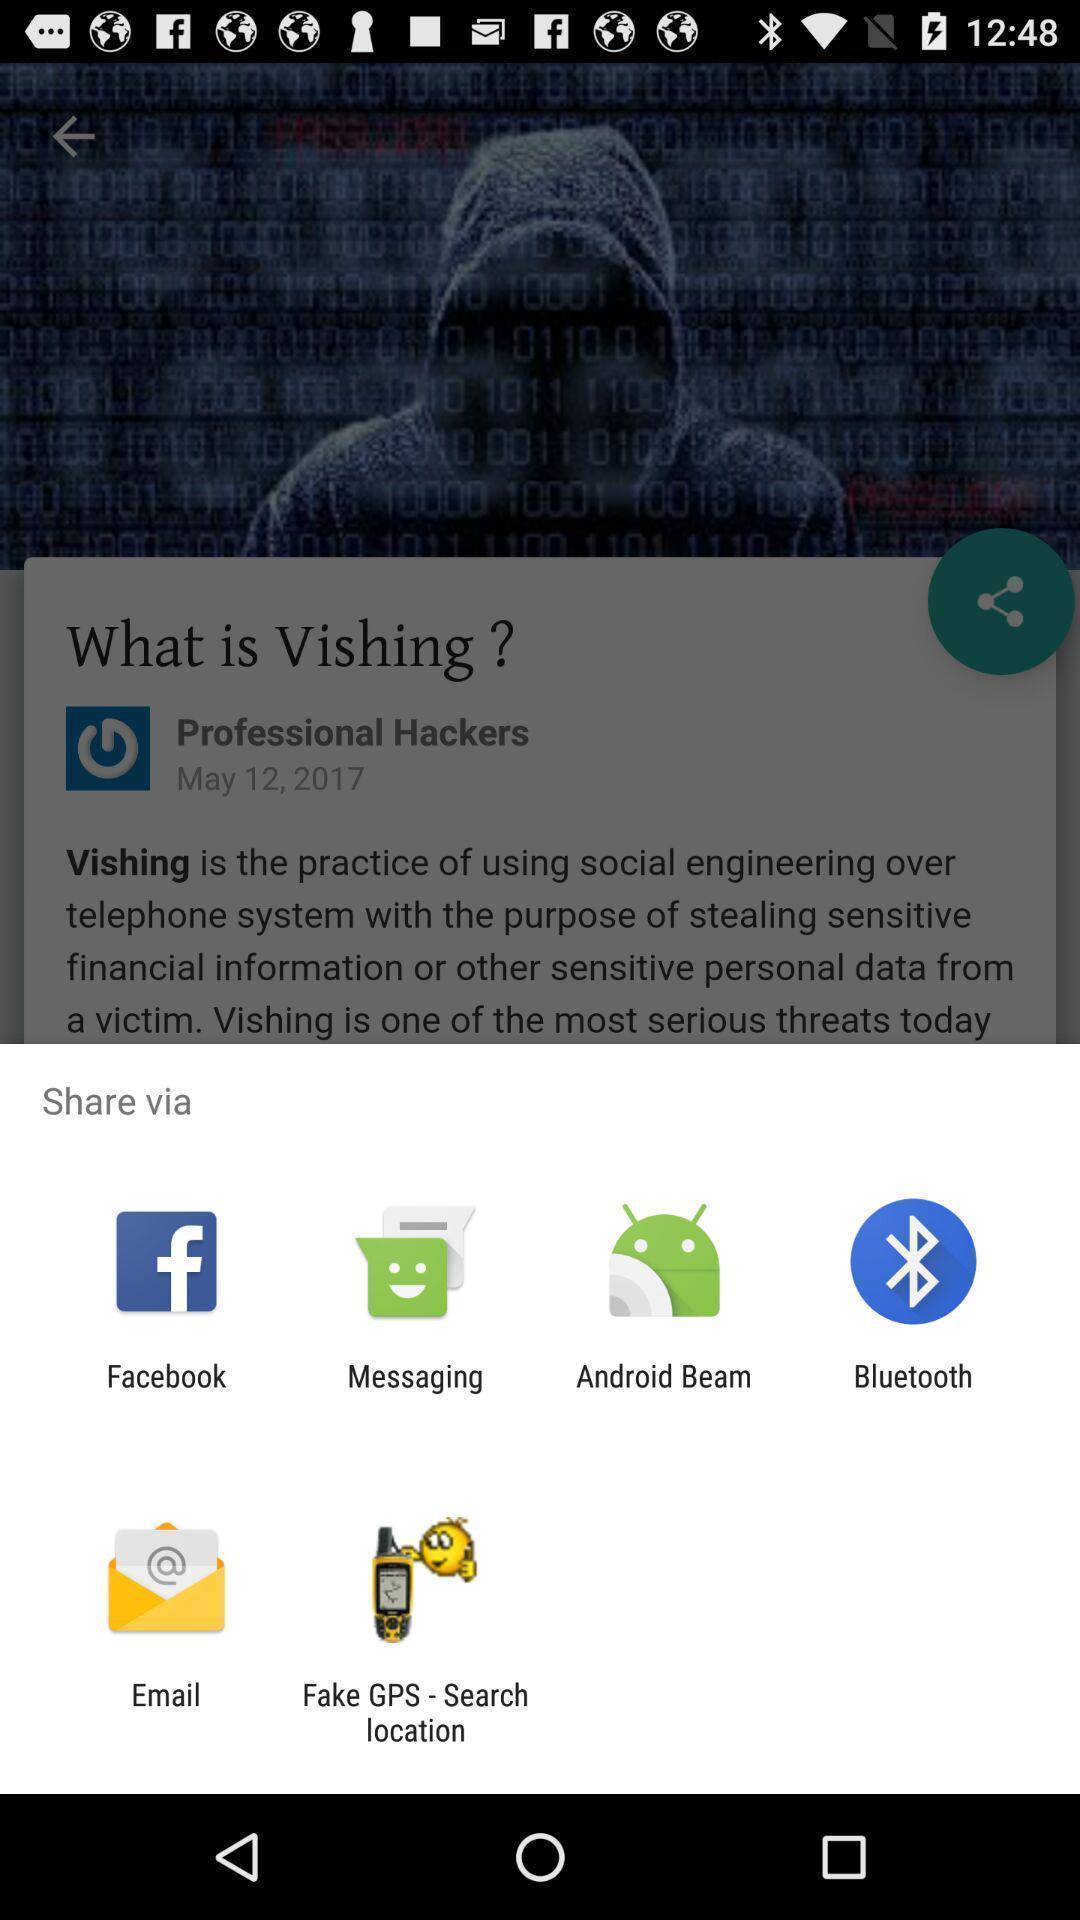Describe the content in this image. Showing various share options. 